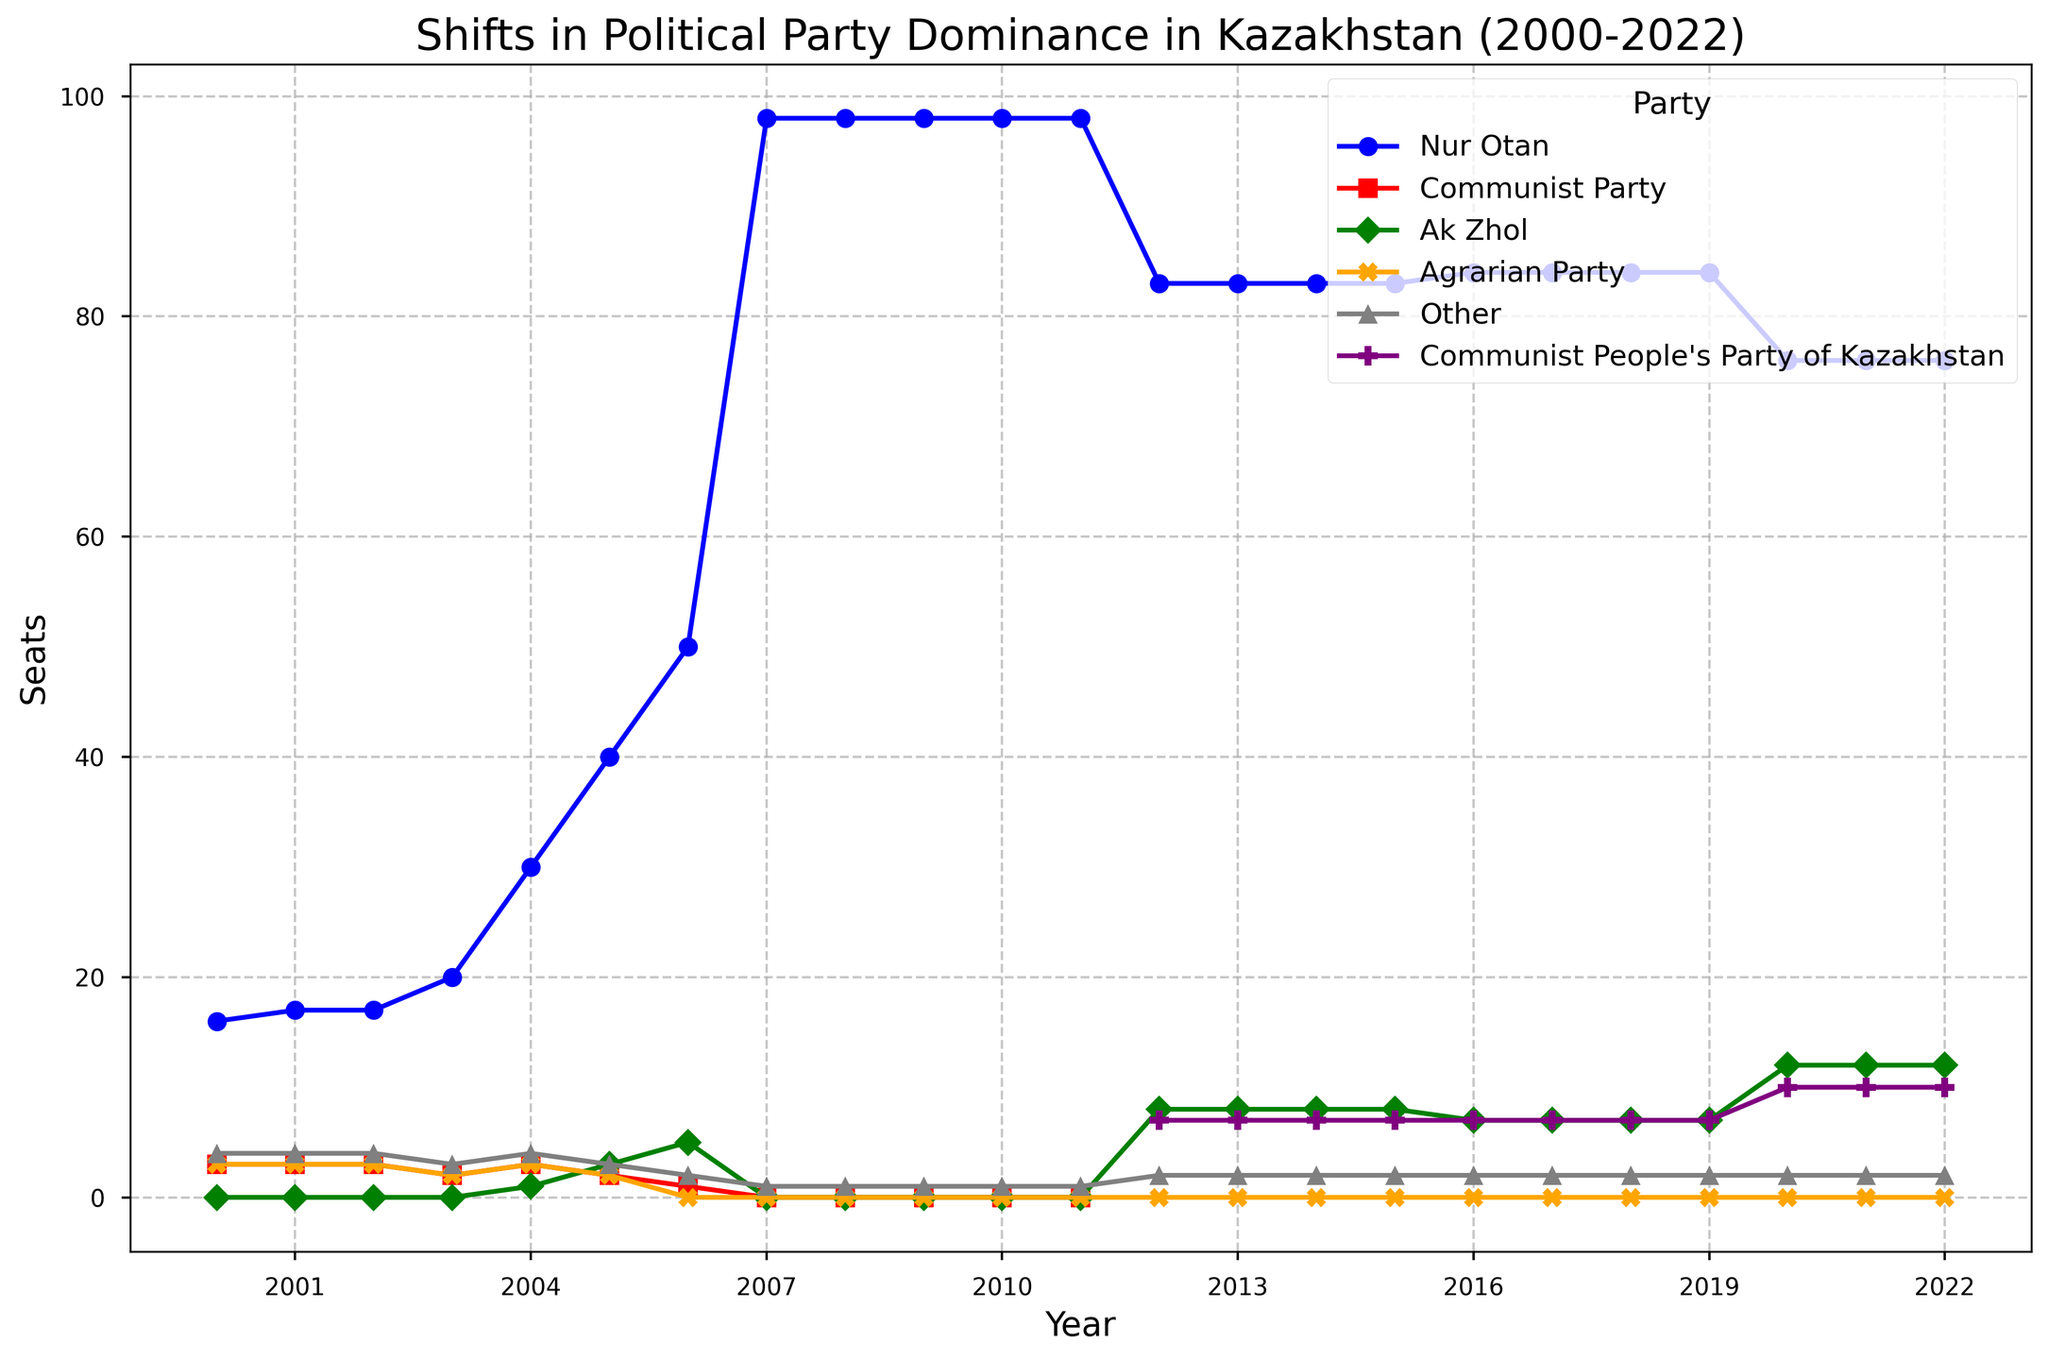Which party held the maximum number of seats in 2000? Looking at the plot for the year 2000, the party with the highest number of seats is shown.
Answer: Nur Otan How many total seats did the Communist Party and the Communist People's Party of Kazakhstan hold in 2007 combined? For 2007, the plot shows that the Communist Party held 0 seats and the Communist People's Party of Kazakhstan was not yet represented.
Answer: 0 What was the change in seats for the Ak Zhol party from 2006 to 2007? Identify the number of seats Ak Zhol had in both 2006 and 2007, then calculate the difference. In 2006, Ak Zhol had 5 seats and in 2007 it had 0. The difference is 5 - 0.
Answer: -5 Which party saw a significant drop in seats between 2006 and 2007? Compare the seat numbers for each party between 2006 and 2007, noting which party experienced a drop. Nur Otan is seen to have a significant increase, not drop, whereas the Agrarian Party lost seats but was already declining. Ak Zhol went to 0 seats.
Answer: Ak Zhol In which year did Nur Otan achieve its peak number of seats between 2000 and 2022? Examine the plot for the highest point on the line representing Nur Otan across all the years.
Answer: 2007 How many years did it take for Ak Zhol to regain seats after it had 0 seats in 2007? Locate the year when Ak Zhol had zero seats (2007) and the next year when it gained seats again (2012). Calculate the difference in years.
Answer: 5 Which party had the most consistent number of seats between 2012 and 2022? Look for the party with the smallest variation in the number of seats during the period from 2012 to 2022. Communist People's Party of Kazakhstan shows consistency with minor changes.
Answer: Communist People's Party of Kazakhstan Did any party surpass the number of seats held by Nur Otan in any given year from 2000 to 2022? Review the plot to see if any party's highest points exceed Nur Otan’s lowest troughs. Despite fluctuations, Nur Otan always maintained more seats than any other party.
Answer: No When did the Communist Party representation drop to zero? Locate the year on the plot when the line for the Communist Party drops to zero.
Answer: 2007 What is the total number of seats held by all the parties combined in 2022? Sum up the seat numbers for each party in the year 2022. Nur Otan: 76, Communist People's Party of Kazakhstan: 10, Ak Zhol: 12, Other: 2. Total: 76+10+12+2
Answer: 100 